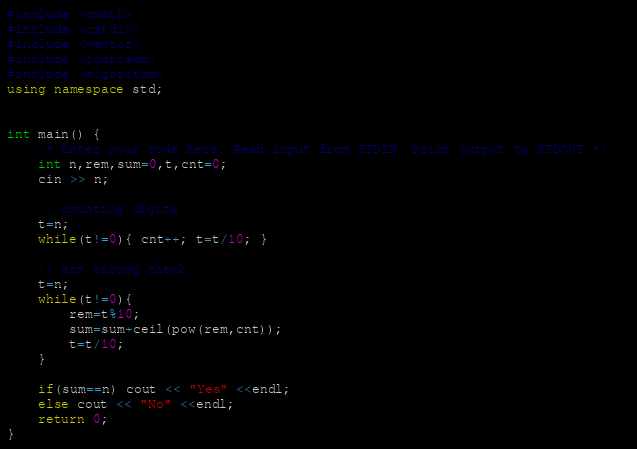Convert code to text. <code><loc_0><loc_0><loc_500><loc_500><_C++_>#include <cmath>
#include <cstdio>
#include <vector>
#include <iostream>
#include <algorithm>
using namespace std;


int main() {
    /* Enter your code here. Read input from STDIN. Print output to STDOUT */   
    int n,rem,sum=0,t,cnt=0;
    cin >> n;
    
    // counting digits
    t=n;
    while(t!=0){ cnt++; t=t/10; }
    
    // arm strong check
    t=n;
    while(t!=0){
        rem=t%10;
        sum=sum+ceil(pow(rem,cnt));
        t=t/10;
    }
    
    if(sum==n) cout << "Yes" <<endl;
    else cout << "No" <<endl;
    return 0;
}
</code> 